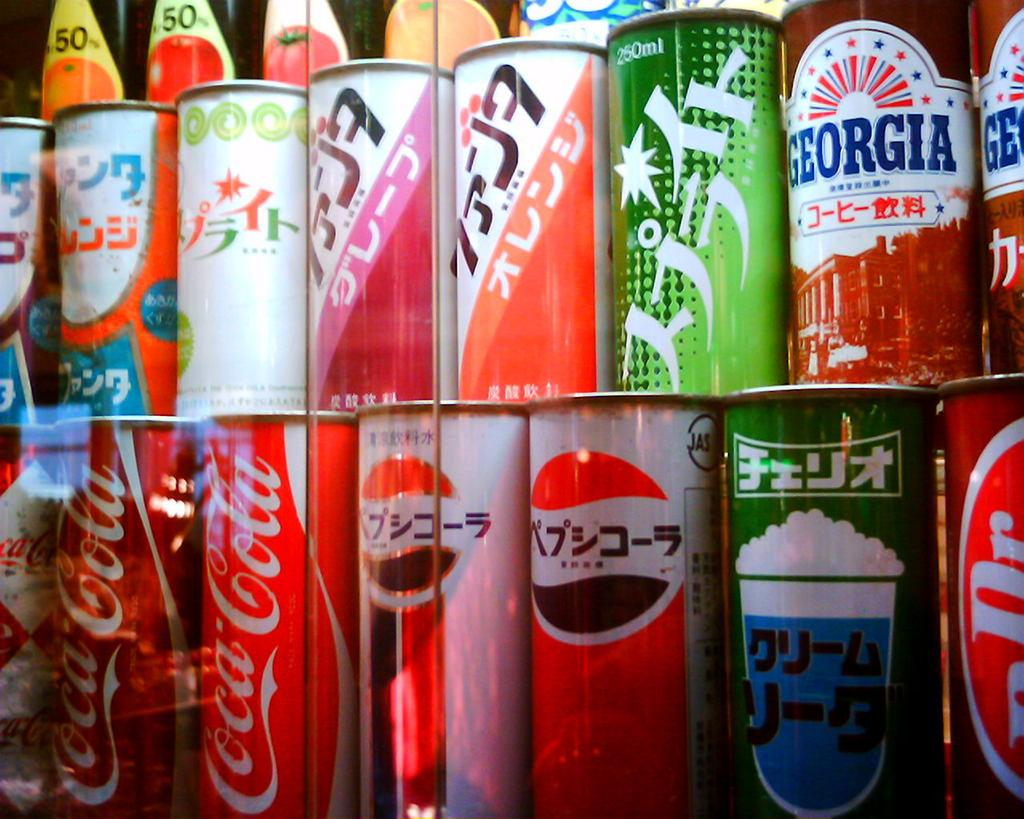What objects are present in the image? There are tins in the image. Can you describe the appearance of the tins? The tins are in different colors. What else can be seen in the background of the image? There are stickers attached to the bottles in the background. What type of cork can be seen in the image? There is no cork present in the image. What is the desire of the tins in the image? Tins do not have desires, as they are inanimate objects. 